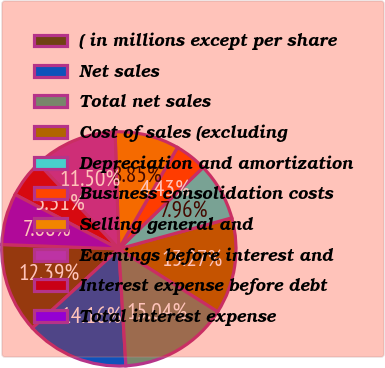Convert chart. <chart><loc_0><loc_0><loc_500><loc_500><pie_chart><fcel>( in millions except per share<fcel>Net sales<fcel>Total net sales<fcel>Cost of sales (excluding<fcel>Depreciation and amortization<fcel>Business consolidation costs<fcel>Selling general and<fcel>Earnings before interest and<fcel>Interest expense before debt<fcel>Total interest expense<nl><fcel>12.39%<fcel>14.16%<fcel>15.04%<fcel>13.27%<fcel>7.96%<fcel>4.43%<fcel>8.85%<fcel>11.5%<fcel>5.31%<fcel>7.08%<nl></chart> 